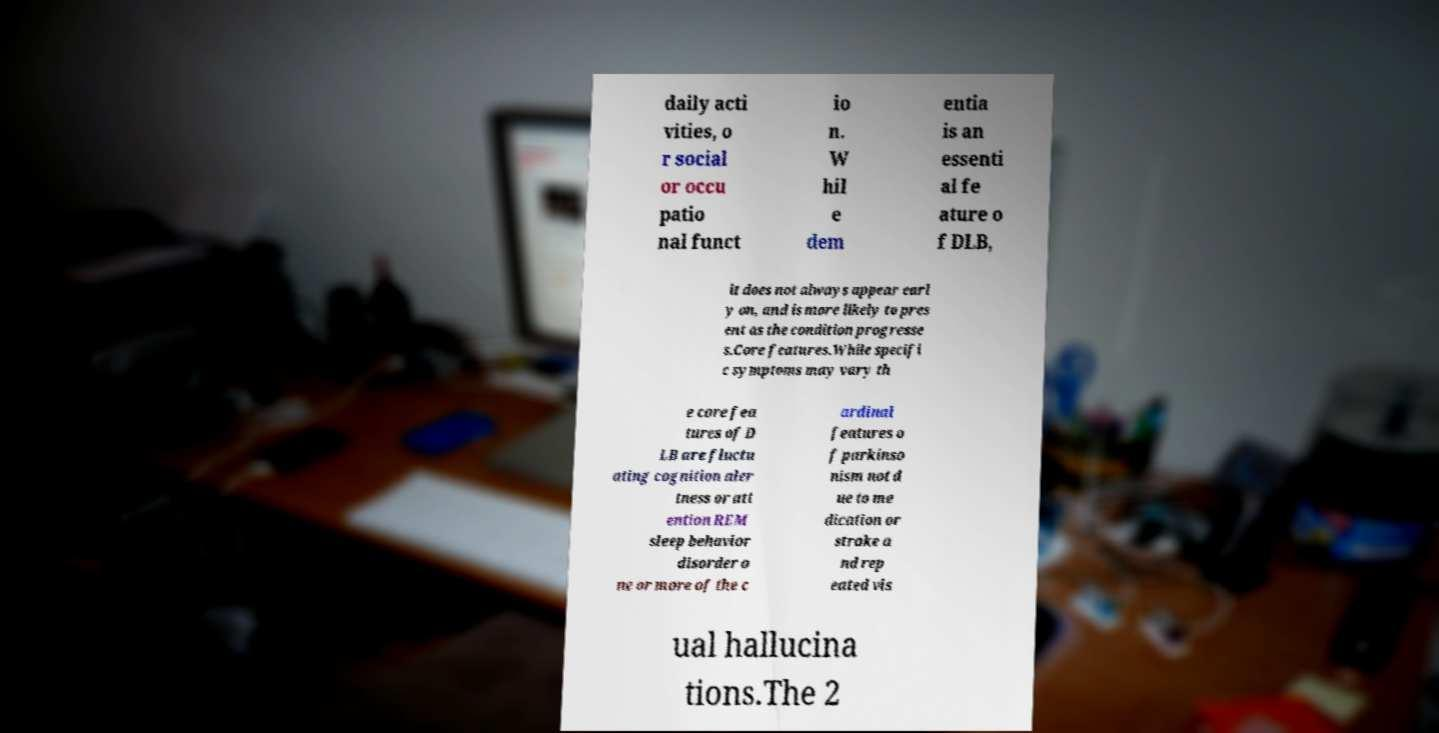Could you extract and type out the text from this image? daily acti vities, o r social or occu patio nal funct io n. W hil e dem entia is an essenti al fe ature o f DLB, it does not always appear earl y on, and is more likely to pres ent as the condition progresse s.Core features.While specifi c symptoms may vary th e core fea tures of D LB are fluctu ating cognition aler tness or att ention REM sleep behavior disorder o ne or more of the c ardinal features o f parkinso nism not d ue to me dication or stroke a nd rep eated vis ual hallucina tions.The 2 